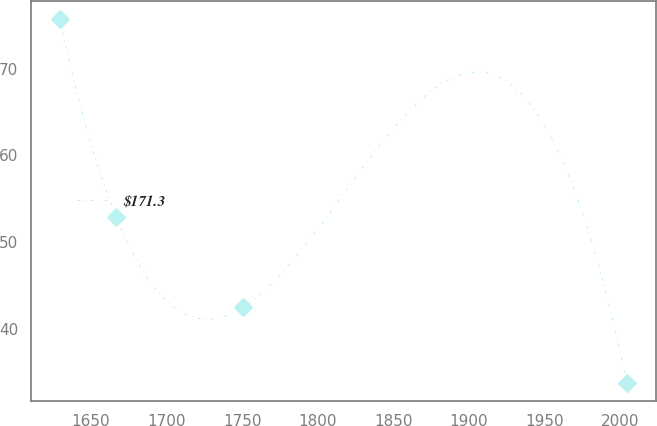Convert chart. <chart><loc_0><loc_0><loc_500><loc_500><line_chart><ecel><fcel>$171.3<nl><fcel>1629.19<fcel>75.72<nl><fcel>1666.75<fcel>52.83<nl><fcel>1750.83<fcel>42.5<nl><fcel>2004.79<fcel>33.71<nl></chart> 